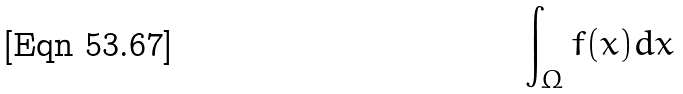Convert formula to latex. <formula><loc_0><loc_0><loc_500><loc_500>\int _ { \Omega } f ( x ) d x</formula> 